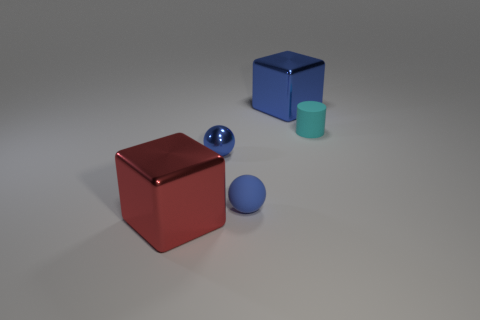Subtract all blue cylinders. Subtract all cyan blocks. How many cylinders are left? 1 Add 4 small objects. How many objects exist? 9 Subtract all cylinders. How many objects are left? 4 Subtract 0 blue cylinders. How many objects are left? 5 Subtract all shiny blocks. Subtract all tiny cyan matte cylinders. How many objects are left? 2 Add 4 small blue matte spheres. How many small blue matte spheres are left? 5 Add 3 small things. How many small things exist? 6 